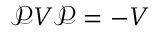<formula> <loc_0><loc_0><loc_500><loc_500>\mathcal { P } V \mathcal { P } = - V</formula> 